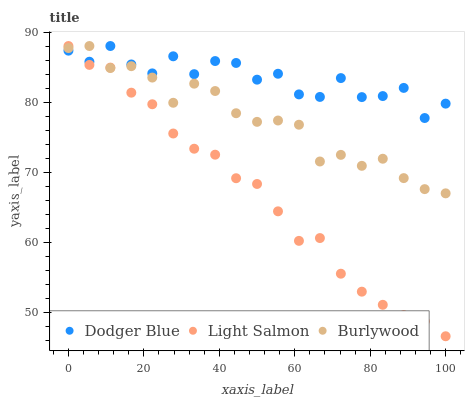Does Light Salmon have the minimum area under the curve?
Answer yes or no. Yes. Does Dodger Blue have the maximum area under the curve?
Answer yes or no. Yes. Does Dodger Blue have the minimum area under the curve?
Answer yes or no. No. Does Light Salmon have the maximum area under the curve?
Answer yes or no. No. Is Light Salmon the smoothest?
Answer yes or no. Yes. Is Dodger Blue the roughest?
Answer yes or no. Yes. Is Dodger Blue the smoothest?
Answer yes or no. No. Is Light Salmon the roughest?
Answer yes or no. No. Does Light Salmon have the lowest value?
Answer yes or no. Yes. Does Dodger Blue have the lowest value?
Answer yes or no. No. Does Dodger Blue have the highest value?
Answer yes or no. Yes. Does Dodger Blue intersect Burlywood?
Answer yes or no. Yes. Is Dodger Blue less than Burlywood?
Answer yes or no. No. Is Dodger Blue greater than Burlywood?
Answer yes or no. No. 